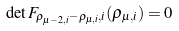<formula> <loc_0><loc_0><loc_500><loc_500>\det F _ { \rho _ { \mu - 2 , i } - \rho _ { \mu , i } , i } ( \rho _ { \mu , i } ) = 0</formula> 